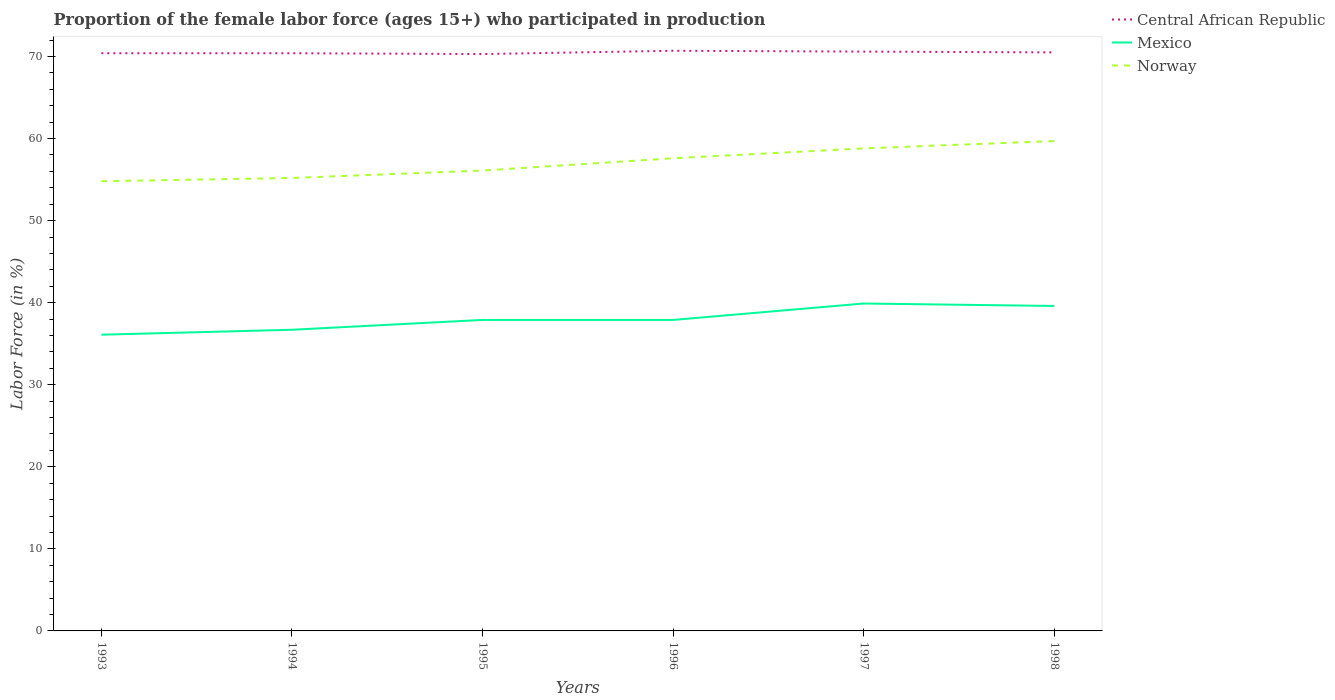How many different coloured lines are there?
Give a very brief answer. 3. Does the line corresponding to Norway intersect with the line corresponding to Mexico?
Keep it short and to the point. No. Across all years, what is the maximum proportion of the female labor force who participated in production in Central African Republic?
Provide a short and direct response. 70.3. What is the total proportion of the female labor force who participated in production in Central African Republic in the graph?
Your answer should be compact. 0. What is the difference between the highest and the second highest proportion of the female labor force who participated in production in Central African Republic?
Keep it short and to the point. 0.4. What is the difference between the highest and the lowest proportion of the female labor force who participated in production in Norway?
Provide a short and direct response. 3. Is the proportion of the female labor force who participated in production in Central African Republic strictly greater than the proportion of the female labor force who participated in production in Norway over the years?
Offer a terse response. No. How many lines are there?
Provide a short and direct response. 3. How many years are there in the graph?
Provide a succinct answer. 6. What is the difference between two consecutive major ticks on the Y-axis?
Your response must be concise. 10. Does the graph contain any zero values?
Offer a very short reply. No. Where does the legend appear in the graph?
Provide a short and direct response. Top right. How many legend labels are there?
Provide a succinct answer. 3. What is the title of the graph?
Make the answer very short. Proportion of the female labor force (ages 15+) who participated in production. Does "Curacao" appear as one of the legend labels in the graph?
Provide a short and direct response. No. What is the label or title of the X-axis?
Your answer should be very brief. Years. What is the label or title of the Y-axis?
Provide a short and direct response. Labor Force (in %). What is the Labor Force (in %) in Central African Republic in 1993?
Offer a very short reply. 70.4. What is the Labor Force (in %) of Mexico in 1993?
Your response must be concise. 36.1. What is the Labor Force (in %) in Norway in 1993?
Offer a very short reply. 54.8. What is the Labor Force (in %) in Central African Republic in 1994?
Your response must be concise. 70.4. What is the Labor Force (in %) in Mexico in 1994?
Offer a very short reply. 36.7. What is the Labor Force (in %) in Norway in 1994?
Keep it short and to the point. 55.2. What is the Labor Force (in %) of Central African Republic in 1995?
Your answer should be very brief. 70.3. What is the Labor Force (in %) in Mexico in 1995?
Provide a short and direct response. 37.9. What is the Labor Force (in %) in Norway in 1995?
Your answer should be very brief. 56.1. What is the Labor Force (in %) of Central African Republic in 1996?
Provide a short and direct response. 70.7. What is the Labor Force (in %) of Mexico in 1996?
Your response must be concise. 37.9. What is the Labor Force (in %) of Norway in 1996?
Ensure brevity in your answer.  57.6. What is the Labor Force (in %) in Central African Republic in 1997?
Keep it short and to the point. 70.6. What is the Labor Force (in %) of Mexico in 1997?
Offer a very short reply. 39.9. What is the Labor Force (in %) of Norway in 1997?
Offer a very short reply. 58.8. What is the Labor Force (in %) in Central African Republic in 1998?
Give a very brief answer. 70.5. What is the Labor Force (in %) in Mexico in 1998?
Your answer should be compact. 39.6. What is the Labor Force (in %) of Norway in 1998?
Offer a terse response. 59.7. Across all years, what is the maximum Labor Force (in %) in Central African Republic?
Your answer should be very brief. 70.7. Across all years, what is the maximum Labor Force (in %) of Mexico?
Your answer should be compact. 39.9. Across all years, what is the maximum Labor Force (in %) in Norway?
Provide a succinct answer. 59.7. Across all years, what is the minimum Labor Force (in %) of Central African Republic?
Your answer should be very brief. 70.3. Across all years, what is the minimum Labor Force (in %) in Mexico?
Your response must be concise. 36.1. Across all years, what is the minimum Labor Force (in %) in Norway?
Your answer should be very brief. 54.8. What is the total Labor Force (in %) in Central African Republic in the graph?
Offer a very short reply. 422.9. What is the total Labor Force (in %) of Mexico in the graph?
Keep it short and to the point. 228.1. What is the total Labor Force (in %) of Norway in the graph?
Ensure brevity in your answer.  342.2. What is the difference between the Labor Force (in %) of Central African Republic in 1993 and that in 1994?
Ensure brevity in your answer.  0. What is the difference between the Labor Force (in %) in Mexico in 1993 and that in 1994?
Ensure brevity in your answer.  -0.6. What is the difference between the Labor Force (in %) of Central African Republic in 1993 and that in 1995?
Ensure brevity in your answer.  0.1. What is the difference between the Labor Force (in %) of Mexico in 1993 and that in 1996?
Give a very brief answer. -1.8. What is the difference between the Labor Force (in %) in Norway in 1993 and that in 1996?
Your answer should be compact. -2.8. What is the difference between the Labor Force (in %) in Central African Republic in 1993 and that in 1997?
Ensure brevity in your answer.  -0.2. What is the difference between the Labor Force (in %) in Central African Republic in 1993 and that in 1998?
Offer a very short reply. -0.1. What is the difference between the Labor Force (in %) of Mexico in 1993 and that in 1998?
Your answer should be compact. -3.5. What is the difference between the Labor Force (in %) in Central African Republic in 1994 and that in 1995?
Provide a succinct answer. 0.1. What is the difference between the Labor Force (in %) in Mexico in 1994 and that in 1995?
Your response must be concise. -1.2. What is the difference between the Labor Force (in %) of Mexico in 1994 and that in 1996?
Offer a terse response. -1.2. What is the difference between the Labor Force (in %) of Central African Republic in 1994 and that in 1997?
Provide a succinct answer. -0.2. What is the difference between the Labor Force (in %) in Norway in 1994 and that in 1997?
Keep it short and to the point. -3.6. What is the difference between the Labor Force (in %) of Norway in 1994 and that in 1998?
Your answer should be compact. -4.5. What is the difference between the Labor Force (in %) in Mexico in 1995 and that in 1997?
Keep it short and to the point. -2. What is the difference between the Labor Force (in %) of Norway in 1995 and that in 1997?
Offer a terse response. -2.7. What is the difference between the Labor Force (in %) of Central African Republic in 1995 and that in 1998?
Keep it short and to the point. -0.2. What is the difference between the Labor Force (in %) in Norway in 1995 and that in 1998?
Ensure brevity in your answer.  -3.6. What is the difference between the Labor Force (in %) of Central African Republic in 1996 and that in 1997?
Keep it short and to the point. 0.1. What is the difference between the Labor Force (in %) in Mexico in 1996 and that in 1997?
Your answer should be compact. -2. What is the difference between the Labor Force (in %) in Norway in 1996 and that in 1997?
Your answer should be compact. -1.2. What is the difference between the Labor Force (in %) in Central African Republic in 1996 and that in 1998?
Offer a very short reply. 0.2. What is the difference between the Labor Force (in %) in Mexico in 1996 and that in 1998?
Offer a very short reply. -1.7. What is the difference between the Labor Force (in %) in Norway in 1996 and that in 1998?
Your response must be concise. -2.1. What is the difference between the Labor Force (in %) in Central African Republic in 1997 and that in 1998?
Keep it short and to the point. 0.1. What is the difference between the Labor Force (in %) of Norway in 1997 and that in 1998?
Your answer should be very brief. -0.9. What is the difference between the Labor Force (in %) in Central African Republic in 1993 and the Labor Force (in %) in Mexico in 1994?
Keep it short and to the point. 33.7. What is the difference between the Labor Force (in %) of Mexico in 1993 and the Labor Force (in %) of Norway in 1994?
Make the answer very short. -19.1. What is the difference between the Labor Force (in %) of Central African Republic in 1993 and the Labor Force (in %) of Mexico in 1995?
Offer a terse response. 32.5. What is the difference between the Labor Force (in %) of Central African Republic in 1993 and the Labor Force (in %) of Norway in 1995?
Provide a short and direct response. 14.3. What is the difference between the Labor Force (in %) of Mexico in 1993 and the Labor Force (in %) of Norway in 1995?
Keep it short and to the point. -20. What is the difference between the Labor Force (in %) of Central African Republic in 1993 and the Labor Force (in %) of Mexico in 1996?
Provide a short and direct response. 32.5. What is the difference between the Labor Force (in %) in Central African Republic in 1993 and the Labor Force (in %) in Norway in 1996?
Your response must be concise. 12.8. What is the difference between the Labor Force (in %) in Mexico in 1993 and the Labor Force (in %) in Norway in 1996?
Offer a very short reply. -21.5. What is the difference between the Labor Force (in %) in Central African Republic in 1993 and the Labor Force (in %) in Mexico in 1997?
Provide a short and direct response. 30.5. What is the difference between the Labor Force (in %) of Mexico in 1993 and the Labor Force (in %) of Norway in 1997?
Keep it short and to the point. -22.7. What is the difference between the Labor Force (in %) in Central African Republic in 1993 and the Labor Force (in %) in Mexico in 1998?
Keep it short and to the point. 30.8. What is the difference between the Labor Force (in %) in Mexico in 1993 and the Labor Force (in %) in Norway in 1998?
Provide a succinct answer. -23.6. What is the difference between the Labor Force (in %) of Central African Republic in 1994 and the Labor Force (in %) of Mexico in 1995?
Ensure brevity in your answer.  32.5. What is the difference between the Labor Force (in %) of Central African Republic in 1994 and the Labor Force (in %) of Norway in 1995?
Keep it short and to the point. 14.3. What is the difference between the Labor Force (in %) in Mexico in 1994 and the Labor Force (in %) in Norway in 1995?
Keep it short and to the point. -19.4. What is the difference between the Labor Force (in %) in Central African Republic in 1994 and the Labor Force (in %) in Mexico in 1996?
Make the answer very short. 32.5. What is the difference between the Labor Force (in %) of Mexico in 1994 and the Labor Force (in %) of Norway in 1996?
Your response must be concise. -20.9. What is the difference between the Labor Force (in %) in Central African Republic in 1994 and the Labor Force (in %) in Mexico in 1997?
Keep it short and to the point. 30.5. What is the difference between the Labor Force (in %) of Mexico in 1994 and the Labor Force (in %) of Norway in 1997?
Give a very brief answer. -22.1. What is the difference between the Labor Force (in %) of Central African Republic in 1994 and the Labor Force (in %) of Mexico in 1998?
Offer a terse response. 30.8. What is the difference between the Labor Force (in %) of Central African Republic in 1995 and the Labor Force (in %) of Mexico in 1996?
Your answer should be very brief. 32.4. What is the difference between the Labor Force (in %) of Mexico in 1995 and the Labor Force (in %) of Norway in 1996?
Offer a very short reply. -19.7. What is the difference between the Labor Force (in %) of Central African Republic in 1995 and the Labor Force (in %) of Mexico in 1997?
Ensure brevity in your answer.  30.4. What is the difference between the Labor Force (in %) in Mexico in 1995 and the Labor Force (in %) in Norway in 1997?
Offer a very short reply. -20.9. What is the difference between the Labor Force (in %) in Central African Republic in 1995 and the Labor Force (in %) in Mexico in 1998?
Provide a succinct answer. 30.7. What is the difference between the Labor Force (in %) of Mexico in 1995 and the Labor Force (in %) of Norway in 1998?
Provide a succinct answer. -21.8. What is the difference between the Labor Force (in %) of Central African Republic in 1996 and the Labor Force (in %) of Mexico in 1997?
Make the answer very short. 30.8. What is the difference between the Labor Force (in %) of Central African Republic in 1996 and the Labor Force (in %) of Norway in 1997?
Keep it short and to the point. 11.9. What is the difference between the Labor Force (in %) in Mexico in 1996 and the Labor Force (in %) in Norway in 1997?
Your answer should be very brief. -20.9. What is the difference between the Labor Force (in %) in Central African Republic in 1996 and the Labor Force (in %) in Mexico in 1998?
Make the answer very short. 31.1. What is the difference between the Labor Force (in %) in Central African Republic in 1996 and the Labor Force (in %) in Norway in 1998?
Provide a succinct answer. 11. What is the difference between the Labor Force (in %) of Mexico in 1996 and the Labor Force (in %) of Norway in 1998?
Provide a succinct answer. -21.8. What is the difference between the Labor Force (in %) in Mexico in 1997 and the Labor Force (in %) in Norway in 1998?
Your answer should be very brief. -19.8. What is the average Labor Force (in %) of Central African Republic per year?
Provide a short and direct response. 70.48. What is the average Labor Force (in %) in Mexico per year?
Provide a succinct answer. 38.02. What is the average Labor Force (in %) in Norway per year?
Provide a short and direct response. 57.03. In the year 1993, what is the difference between the Labor Force (in %) of Central African Republic and Labor Force (in %) of Mexico?
Your answer should be compact. 34.3. In the year 1993, what is the difference between the Labor Force (in %) of Central African Republic and Labor Force (in %) of Norway?
Give a very brief answer. 15.6. In the year 1993, what is the difference between the Labor Force (in %) of Mexico and Labor Force (in %) of Norway?
Give a very brief answer. -18.7. In the year 1994, what is the difference between the Labor Force (in %) of Central African Republic and Labor Force (in %) of Mexico?
Your answer should be compact. 33.7. In the year 1994, what is the difference between the Labor Force (in %) in Mexico and Labor Force (in %) in Norway?
Give a very brief answer. -18.5. In the year 1995, what is the difference between the Labor Force (in %) in Central African Republic and Labor Force (in %) in Mexico?
Give a very brief answer. 32.4. In the year 1995, what is the difference between the Labor Force (in %) in Central African Republic and Labor Force (in %) in Norway?
Give a very brief answer. 14.2. In the year 1995, what is the difference between the Labor Force (in %) in Mexico and Labor Force (in %) in Norway?
Make the answer very short. -18.2. In the year 1996, what is the difference between the Labor Force (in %) in Central African Republic and Labor Force (in %) in Mexico?
Offer a terse response. 32.8. In the year 1996, what is the difference between the Labor Force (in %) in Central African Republic and Labor Force (in %) in Norway?
Ensure brevity in your answer.  13.1. In the year 1996, what is the difference between the Labor Force (in %) of Mexico and Labor Force (in %) of Norway?
Ensure brevity in your answer.  -19.7. In the year 1997, what is the difference between the Labor Force (in %) of Central African Republic and Labor Force (in %) of Mexico?
Offer a very short reply. 30.7. In the year 1997, what is the difference between the Labor Force (in %) in Mexico and Labor Force (in %) in Norway?
Ensure brevity in your answer.  -18.9. In the year 1998, what is the difference between the Labor Force (in %) of Central African Republic and Labor Force (in %) of Mexico?
Provide a succinct answer. 30.9. In the year 1998, what is the difference between the Labor Force (in %) of Central African Republic and Labor Force (in %) of Norway?
Your response must be concise. 10.8. In the year 1998, what is the difference between the Labor Force (in %) of Mexico and Labor Force (in %) of Norway?
Offer a very short reply. -20.1. What is the ratio of the Labor Force (in %) of Mexico in 1993 to that in 1994?
Your answer should be very brief. 0.98. What is the ratio of the Labor Force (in %) of Norway in 1993 to that in 1994?
Provide a short and direct response. 0.99. What is the ratio of the Labor Force (in %) of Mexico in 1993 to that in 1995?
Keep it short and to the point. 0.95. What is the ratio of the Labor Force (in %) of Norway in 1993 to that in 1995?
Give a very brief answer. 0.98. What is the ratio of the Labor Force (in %) in Central African Republic in 1993 to that in 1996?
Ensure brevity in your answer.  1. What is the ratio of the Labor Force (in %) in Mexico in 1993 to that in 1996?
Offer a terse response. 0.95. What is the ratio of the Labor Force (in %) of Norway in 1993 to that in 1996?
Give a very brief answer. 0.95. What is the ratio of the Labor Force (in %) of Mexico in 1993 to that in 1997?
Your response must be concise. 0.9. What is the ratio of the Labor Force (in %) of Norway in 1993 to that in 1997?
Provide a short and direct response. 0.93. What is the ratio of the Labor Force (in %) in Mexico in 1993 to that in 1998?
Your answer should be compact. 0.91. What is the ratio of the Labor Force (in %) of Norway in 1993 to that in 1998?
Make the answer very short. 0.92. What is the ratio of the Labor Force (in %) of Mexico in 1994 to that in 1995?
Your answer should be compact. 0.97. What is the ratio of the Labor Force (in %) in Central African Republic in 1994 to that in 1996?
Ensure brevity in your answer.  1. What is the ratio of the Labor Force (in %) of Mexico in 1994 to that in 1996?
Make the answer very short. 0.97. What is the ratio of the Labor Force (in %) of Norway in 1994 to that in 1996?
Your answer should be very brief. 0.96. What is the ratio of the Labor Force (in %) of Mexico in 1994 to that in 1997?
Your answer should be very brief. 0.92. What is the ratio of the Labor Force (in %) of Norway in 1994 to that in 1997?
Give a very brief answer. 0.94. What is the ratio of the Labor Force (in %) of Central African Republic in 1994 to that in 1998?
Ensure brevity in your answer.  1. What is the ratio of the Labor Force (in %) of Mexico in 1994 to that in 1998?
Provide a short and direct response. 0.93. What is the ratio of the Labor Force (in %) of Norway in 1994 to that in 1998?
Offer a very short reply. 0.92. What is the ratio of the Labor Force (in %) of Central African Republic in 1995 to that in 1996?
Make the answer very short. 0.99. What is the ratio of the Labor Force (in %) of Mexico in 1995 to that in 1996?
Your response must be concise. 1. What is the ratio of the Labor Force (in %) of Norway in 1995 to that in 1996?
Keep it short and to the point. 0.97. What is the ratio of the Labor Force (in %) of Central African Republic in 1995 to that in 1997?
Make the answer very short. 1. What is the ratio of the Labor Force (in %) in Mexico in 1995 to that in 1997?
Your answer should be very brief. 0.95. What is the ratio of the Labor Force (in %) in Norway in 1995 to that in 1997?
Your response must be concise. 0.95. What is the ratio of the Labor Force (in %) in Mexico in 1995 to that in 1998?
Provide a short and direct response. 0.96. What is the ratio of the Labor Force (in %) of Norway in 1995 to that in 1998?
Your response must be concise. 0.94. What is the ratio of the Labor Force (in %) of Central African Republic in 1996 to that in 1997?
Provide a succinct answer. 1. What is the ratio of the Labor Force (in %) of Mexico in 1996 to that in 1997?
Keep it short and to the point. 0.95. What is the ratio of the Labor Force (in %) of Norway in 1996 to that in 1997?
Make the answer very short. 0.98. What is the ratio of the Labor Force (in %) in Central African Republic in 1996 to that in 1998?
Keep it short and to the point. 1. What is the ratio of the Labor Force (in %) in Mexico in 1996 to that in 1998?
Ensure brevity in your answer.  0.96. What is the ratio of the Labor Force (in %) of Norway in 1996 to that in 1998?
Your answer should be compact. 0.96. What is the ratio of the Labor Force (in %) of Central African Republic in 1997 to that in 1998?
Keep it short and to the point. 1. What is the ratio of the Labor Force (in %) in Mexico in 1997 to that in 1998?
Your answer should be compact. 1.01. What is the ratio of the Labor Force (in %) in Norway in 1997 to that in 1998?
Ensure brevity in your answer.  0.98. What is the difference between the highest and the second highest Labor Force (in %) of Mexico?
Ensure brevity in your answer.  0.3. What is the difference between the highest and the lowest Labor Force (in %) in Central African Republic?
Keep it short and to the point. 0.4. What is the difference between the highest and the lowest Labor Force (in %) of Mexico?
Offer a terse response. 3.8. 